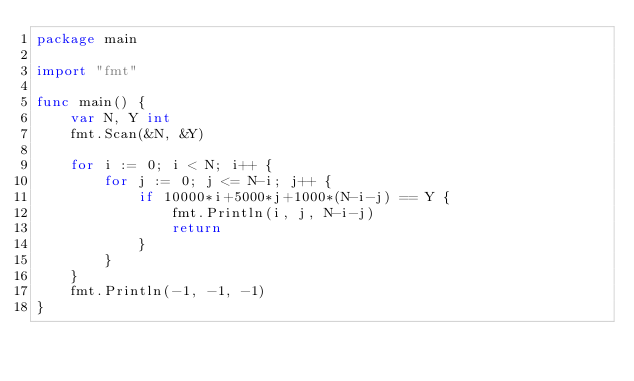<code> <loc_0><loc_0><loc_500><loc_500><_Go_>package main

import "fmt"

func main() {
	var N, Y int
	fmt.Scan(&N, &Y)

	for i := 0; i < N; i++ {
		for j := 0; j <= N-i; j++ {
			if 10000*i+5000*j+1000*(N-i-j) == Y {
				fmt.Println(i, j, N-i-j)
				return
			}
		}
	}
	fmt.Println(-1, -1, -1)
}
</code> 